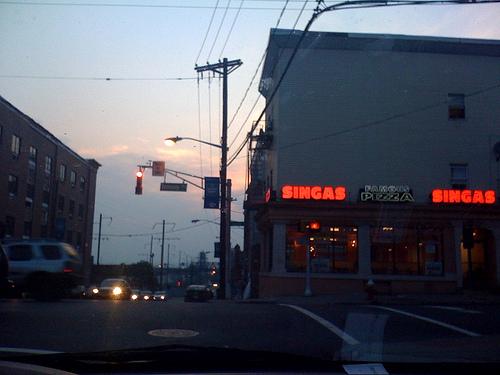How many circles can be seen in the structure?
Write a very short answer. 0. Is it dark outside?
Give a very brief answer. Yes. Do you see a traffic light?
Be succinct. Yes. What food does the restaurant serve?
Short answer required. Pizza. 